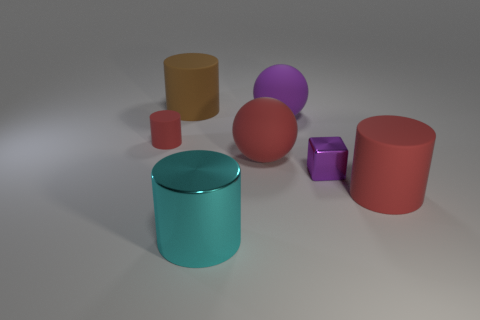There is a metallic thing that is on the left side of the shiny object behind the big cyan shiny cylinder that is in front of the big red sphere; what shape is it?
Offer a terse response. Cylinder. The other large cylinder that is the same material as the brown cylinder is what color?
Your answer should be very brief. Red. There is a large rubber cylinder that is in front of the red rubber cylinder on the left side of the thing right of the small purple shiny cube; what is its color?
Provide a succinct answer. Red. What number of cylinders are either red things or tiny gray matte objects?
Ensure brevity in your answer.  2. There is a big object that is the same color as the block; what is its material?
Ensure brevity in your answer.  Rubber. There is a metal cylinder; is its color the same as the large cylinder right of the tiny purple metal block?
Make the answer very short. No. The small rubber cylinder has what color?
Provide a short and direct response. Red. How many things are cyan objects or tiny brown matte cubes?
Provide a short and direct response. 1. What is the material of the cylinder that is the same size as the metallic cube?
Your answer should be compact. Rubber. What size is the metallic cylinder in front of the purple metal block?
Keep it short and to the point. Large. 